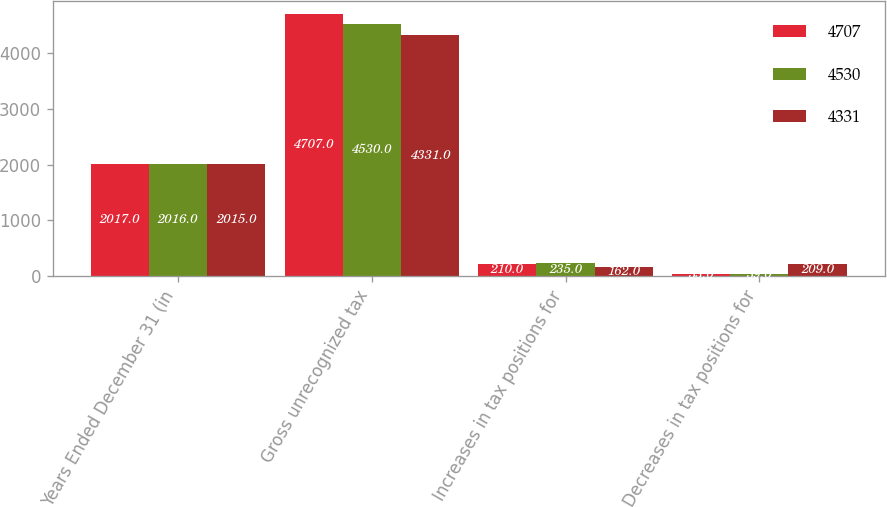Convert chart to OTSL. <chart><loc_0><loc_0><loc_500><loc_500><stacked_bar_chart><ecel><fcel>Years Ended December 31 (in<fcel>Gross unrecognized tax<fcel>Increases in tax positions for<fcel>Decreases in tax positions for<nl><fcel>4707<fcel>2017<fcel>4707<fcel>210<fcel>33<nl><fcel>4530<fcel>2016<fcel>4530<fcel>235<fcel>39<nl><fcel>4331<fcel>2015<fcel>4331<fcel>162<fcel>209<nl></chart> 